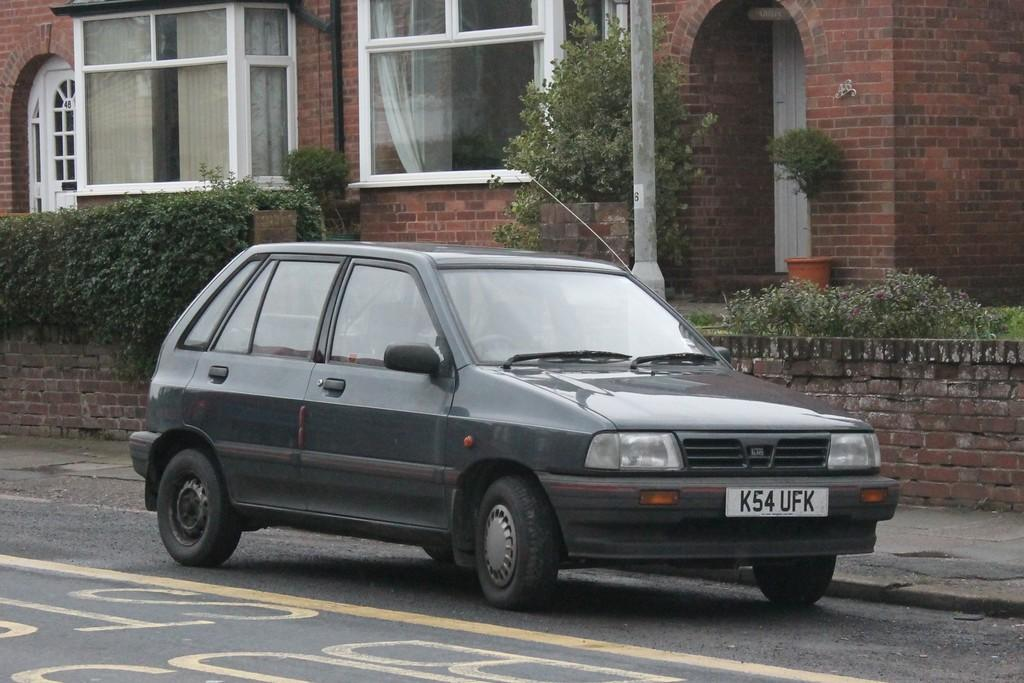What is the main subject of the image? There is a car on the road in the image. What can be seen in the background of the image? There are windows, curtains, doors, a pole, and plants in the background of the image. What type of selection is being made by the car in the image? There is no indication in the image that the car is making any selection. How many balls are visible in the image? There are no balls present in the image. 